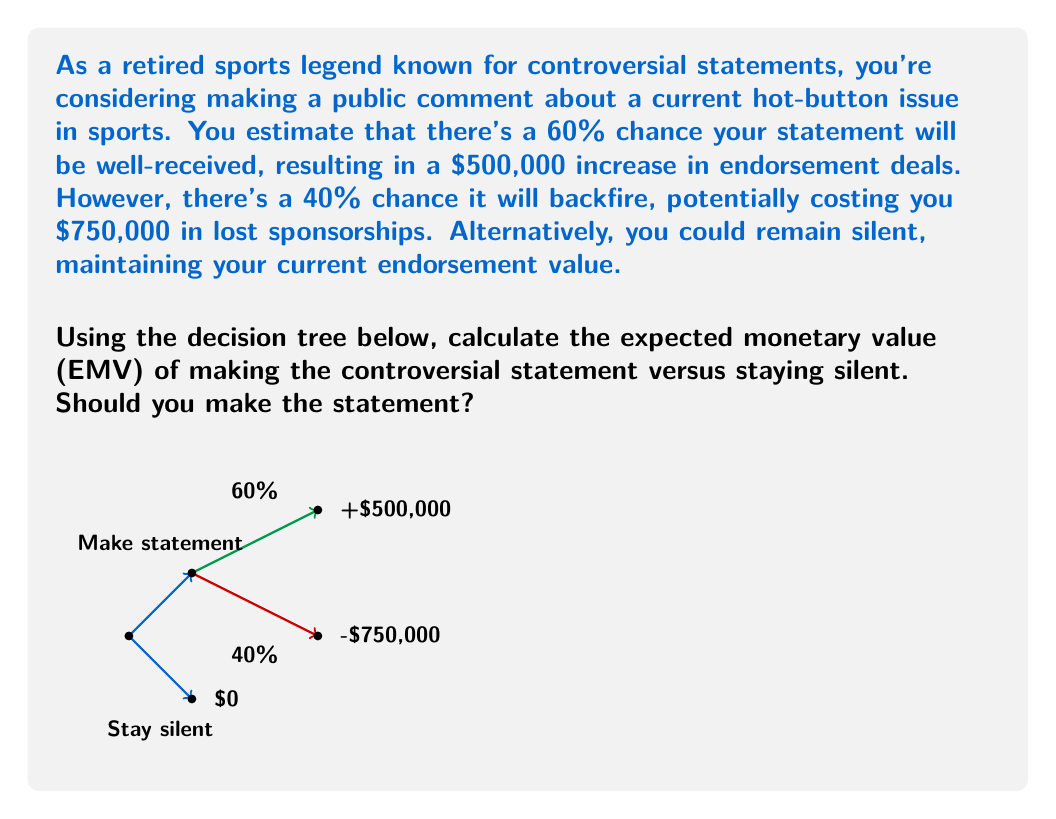Teach me how to tackle this problem. Let's solve this problem step-by-step using decision theory:

1) First, we need to calculate the EMV of making the controversial statement:

   a) Probability of positive outcome: 60% = 0.6
      Value of positive outcome: $500,000
      
   b) Probability of negative outcome: 40% = 0.4
      Value of negative outcome: -$750,000

   EMV of making statement = $(0.6 \times 500,000) + (0.4 \times -750,000)$
                           = $300,000 - 300,000$
                           = $0

2) Now, let's consider the EMV of staying silent:
   EMV of staying silent = $0 (as stated in the question)

3) Compare the two EMVs:
   EMV of making statement: $0
   EMV of staying silent: $0

4) Decision rule: Choose the option with the higher EMV. If they're equal, we can choose either option.

In this case, both options have the same EMV of $0. This means that, purely from a financial expectation standpoint, there's no advantage to either making the statement or staying silent.

However, it's worth noting that making the statement introduces volatility (potential for gain or loss), while staying silent guarantees no change. The choice between these two options would then depend on your risk tolerance and other non-monetary factors.
Answer: EMV(statement) = EMV(silence) = $0. Either choice is mathematically equivalent. 